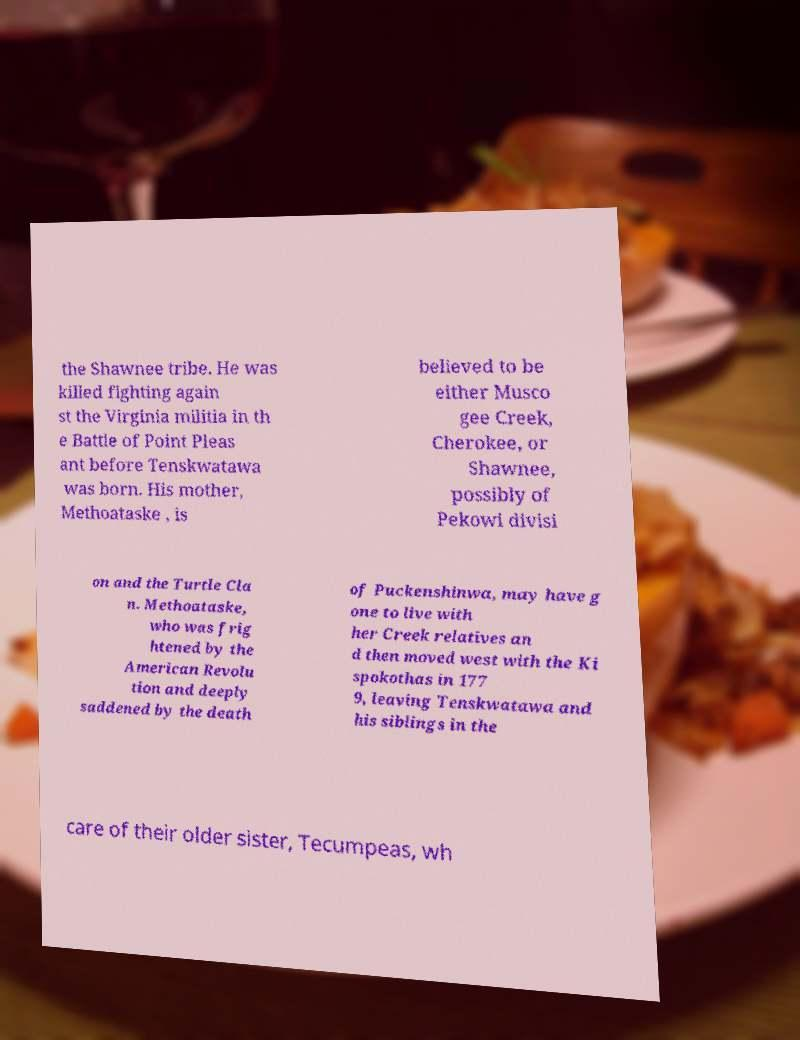Could you assist in decoding the text presented in this image and type it out clearly? the Shawnee tribe. He was killed fighting again st the Virginia militia in th e Battle of Point Pleas ant before Tenskwatawa was born. His mother, Methoataske , is believed to be either Musco gee Creek, Cherokee, or Shawnee, possibly of Pekowi divisi on and the Turtle Cla n. Methoataske, who was frig htened by the American Revolu tion and deeply saddened by the death of Puckenshinwa, may have g one to live with her Creek relatives an d then moved west with the Ki spokothas in 177 9, leaving Tenskwatawa and his siblings in the care of their older sister, Tecumpeas, wh 